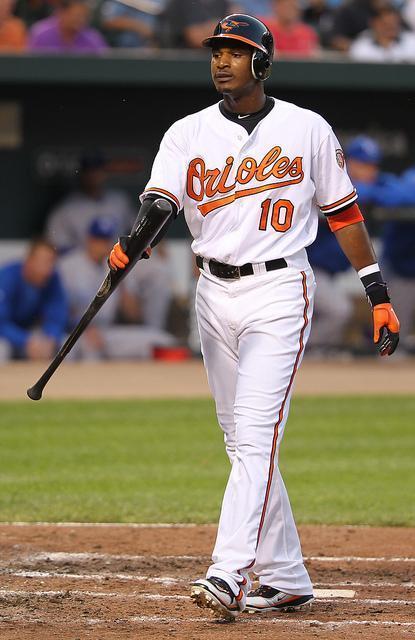How many people are there?
Give a very brief answer. 7. 